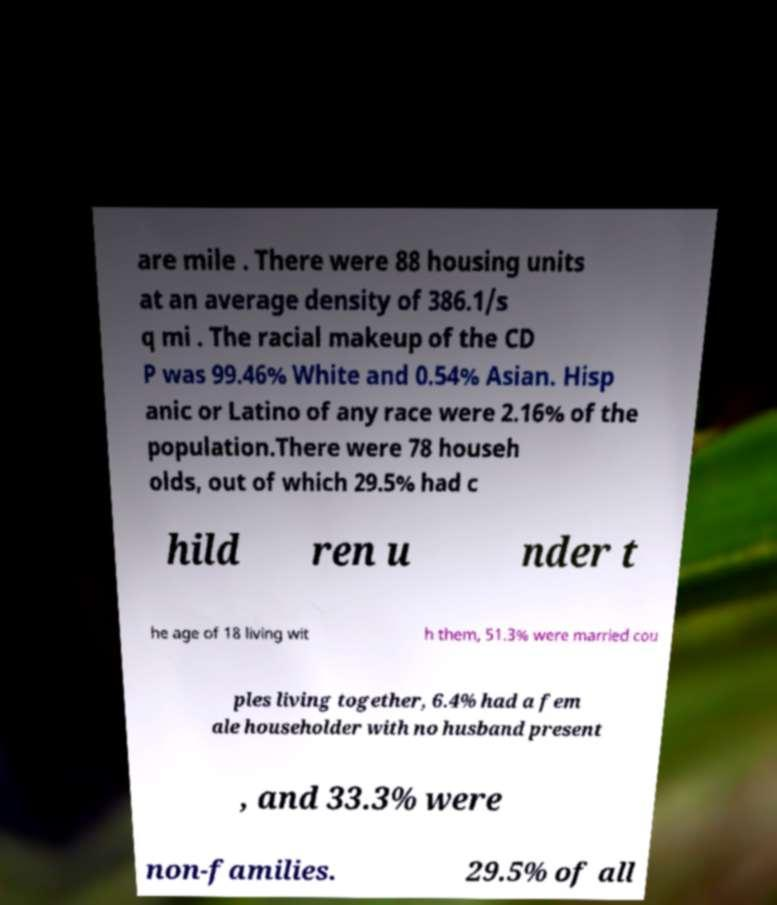Can you read and provide the text displayed in the image?This photo seems to have some interesting text. Can you extract and type it out for me? are mile . There were 88 housing units at an average density of 386.1/s q mi . The racial makeup of the CD P was 99.46% White and 0.54% Asian. Hisp anic or Latino of any race were 2.16% of the population.There were 78 househ olds, out of which 29.5% had c hild ren u nder t he age of 18 living wit h them, 51.3% were married cou ples living together, 6.4% had a fem ale householder with no husband present , and 33.3% were non-families. 29.5% of all 